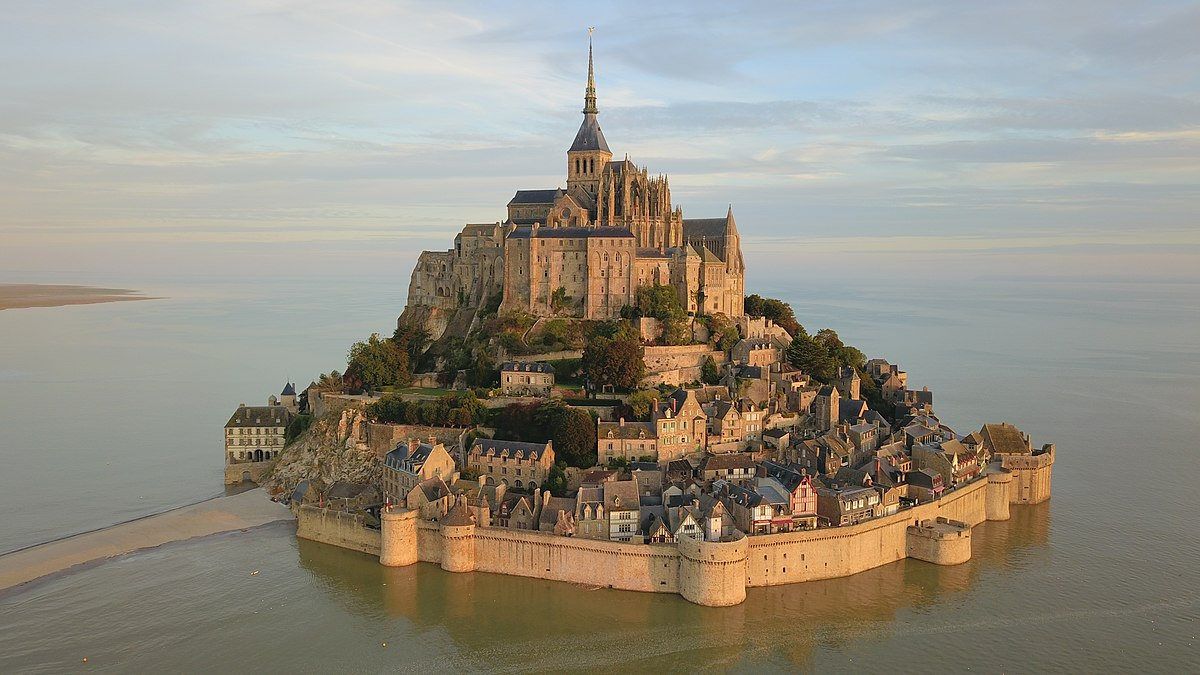Can you paint a short picture of a day in the life of a medieval monk at Mont St Michel? In the cool, misty dawn of Mont St Michel, a medieval monk would rise from a simple straw bed, don his woolen habit, and make his way through the dimly lit corridors to the abbey church for Matins, the first prayer of the day. The sound of chanting fills the air as the monks gather for their sacred rituals. After Matins, the monk might spend time in silent meditation in the cloisters, surrounded by the tranquility of nature and the sea. As the sun rises higher, he joins his brethren in the scriptorium, meticulously copying manuscripts, preserving knowledge and holy texts. The midday meal is a simple affair, consisting of bread, vegetables, and perhaps a bit of fish, eaten in silence as one monk reads aloud from the scriptures. The afternoon brings more labor, either in the gardens tending to herbs and vegetables or in the library continuing his studies. Vespers, the evening prayer, marks the end of the day’s work, followed by a light meal and Compline, the final prayer before retiring for the night. The monk's day is marked by a rhythm of prayer, work, and meditation, all within the sacred walls of Mont St Michel. 